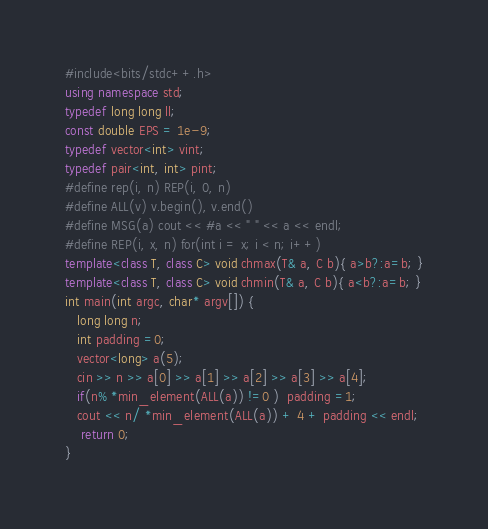Convert code to text. <code><loc_0><loc_0><loc_500><loc_500><_C++_>#include<bits/stdc++.h>
using namespace std;
typedef long long ll;
const double EPS = 1e-9;
typedef vector<int> vint;
typedef pair<int, int> pint;
#define rep(i, n) REP(i, 0, n)
#define ALL(v) v.begin(), v.end()
#define MSG(a) cout << #a << " " << a << endl;
#define REP(i, x, n) for(int i = x; i < n; i++)
template<class T, class C> void chmax(T& a, C b){ a>b?:a=b; }
template<class T, class C> void chmin(T& a, C b){ a<b?:a=b; }
int main(int argc, char* argv[]) {
   long long n;
   int padding =0;
   vector<long> a(5);
   cin >> n >> a[0] >> a[1] >> a[2] >> a[3] >> a[4];
   if(n% *min_element(ALL(a)) !=0 )  padding =1;
   cout << n/ *min_element(ALL(a)) + 4 + padding << endl; 
    return 0;
}

</code> 